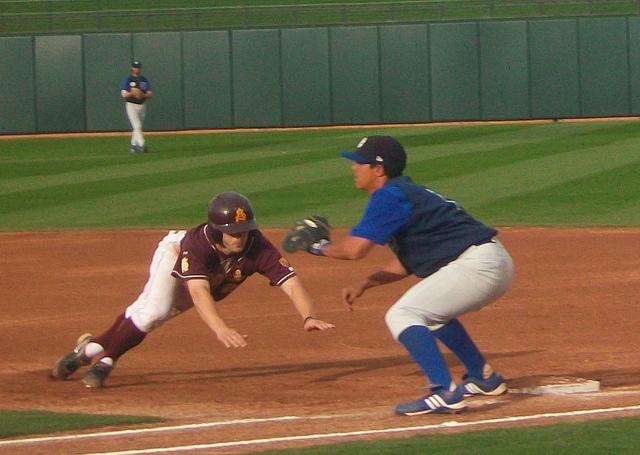Which base is this?
Keep it brief. First. What is the defensive player about to do?
Keep it brief. Catch ball. How many people are wearing helmets?
Give a very brief answer. 1. Who has the ball?
Write a very short answer. Baseman. 